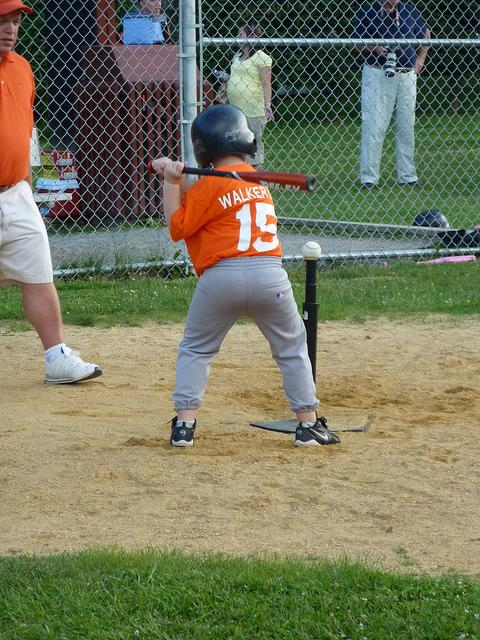What is this kid playing in?

Choices:
A) football
B) little guys
C) little league
D) gone little league 